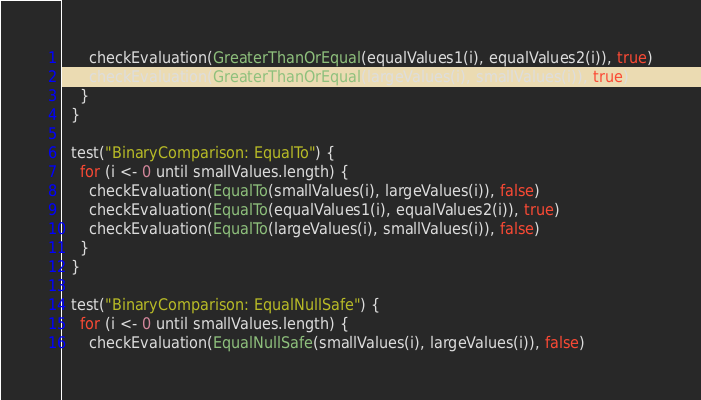<code> <loc_0><loc_0><loc_500><loc_500><_Scala_>      checkEvaluation(GreaterThanOrEqual(equalValues1(i), equalValues2(i)), true)
      checkEvaluation(GreaterThanOrEqual(largeValues(i), smallValues(i)), true)
    }
  }

  test("BinaryComparison: EqualTo") {
    for (i <- 0 until smallValues.length) {
      checkEvaluation(EqualTo(smallValues(i), largeValues(i)), false)
      checkEvaluation(EqualTo(equalValues1(i), equalValues2(i)), true)
      checkEvaluation(EqualTo(largeValues(i), smallValues(i)), false)
    }
  }

  test("BinaryComparison: EqualNullSafe") {
    for (i <- 0 until smallValues.length) {
      checkEvaluation(EqualNullSafe(smallValues(i), largeValues(i)), false)</code> 